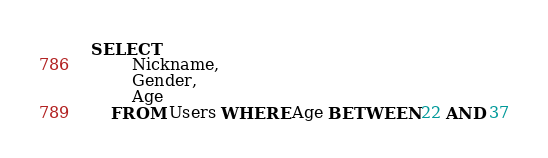<code> <loc_0><loc_0><loc_500><loc_500><_SQL_>SELECT 
		Nickname,
		Gender,
		Age
	FROM Users WHERE Age BETWEEN 22 AND 37</code> 